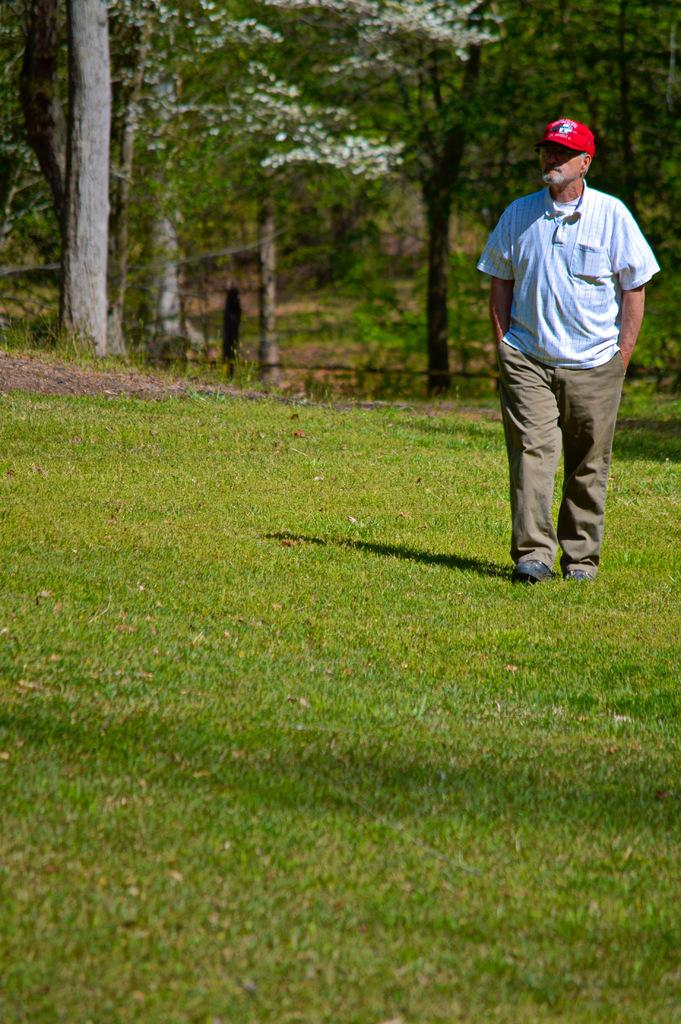Who is the main subject in the image? There is a man in the image. What is the man doing in the image? The man is walking on the ground. What can be seen in the background of the image? There are trees in the background of the image. What color is the grape that the man is holding in the image? There is no grape present in the image; the man is walking on the ground with no visible objects in his hands. 